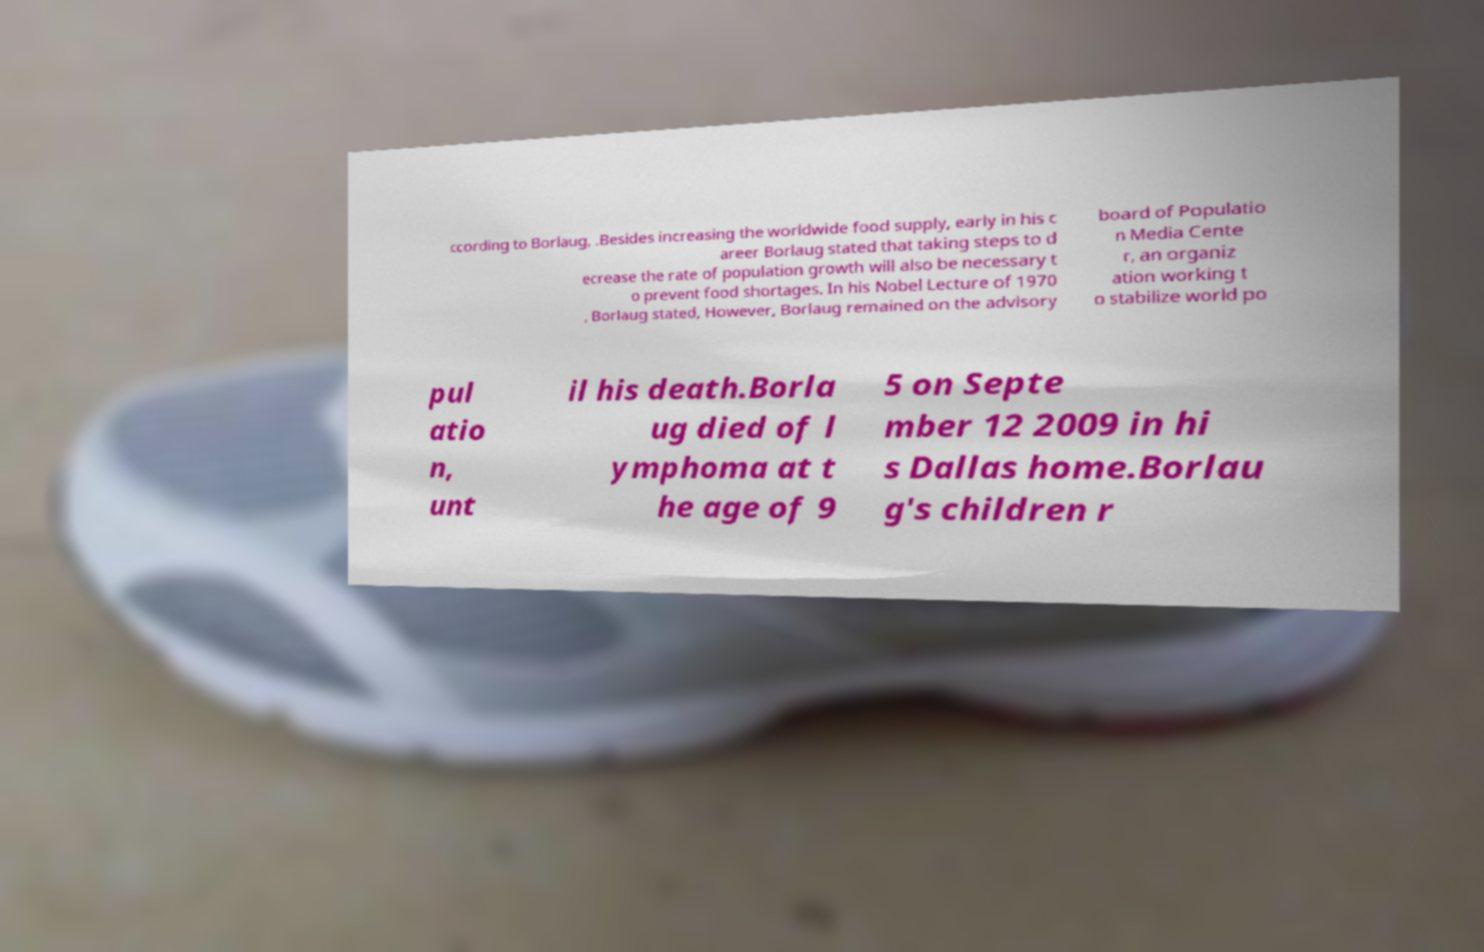Please read and relay the text visible in this image. What does it say? ccording to Borlaug, .Besides increasing the worldwide food supply, early in his c areer Borlaug stated that taking steps to d ecrease the rate of population growth will also be necessary t o prevent food shortages. In his Nobel Lecture of 1970 , Borlaug stated, However, Borlaug remained on the advisory board of Populatio n Media Cente r, an organiz ation working t o stabilize world po pul atio n, unt il his death.Borla ug died of l ymphoma at t he age of 9 5 on Septe mber 12 2009 in hi s Dallas home.Borlau g's children r 